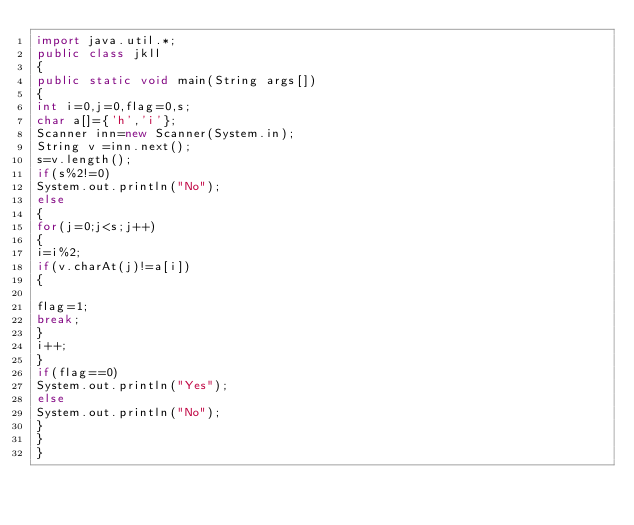Convert code to text. <code><loc_0><loc_0><loc_500><loc_500><_Java_>import java.util.*;
public class jkll
{
public static void main(String args[])
{
int i=0,j=0,flag=0,s;
char a[]={'h','i'};
Scanner inn=new Scanner(System.in);
String v =inn.next();
s=v.length();
if(s%2!=0)
System.out.println("No");
else
{
for(j=0;j<s;j++)
{
i=i%2;
if(v.charAt(j)!=a[i])
{

flag=1;
break;
}
i++;
}
if(flag==0)
System.out.println("Yes");
else
System.out.println("No");
}
}
}</code> 